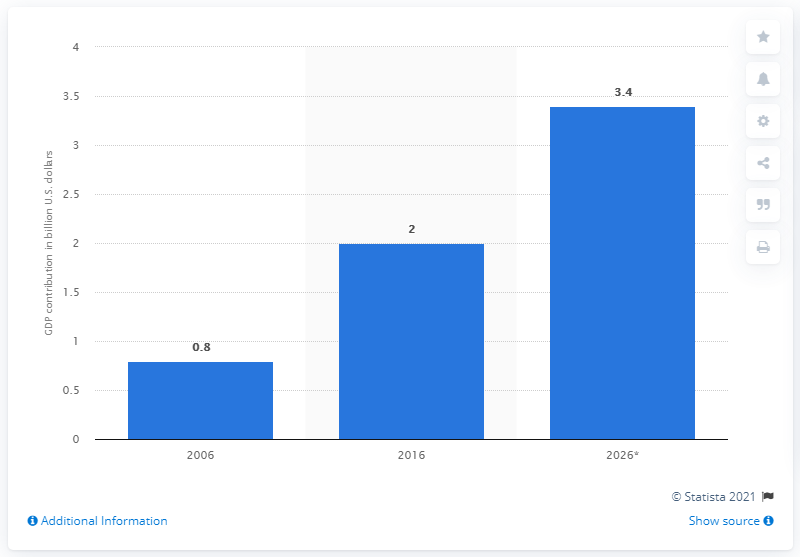List a handful of essential elements in this visual. In 2026, Lagos' direct tourism contribution to Nigeria's GDP was 3.4%. 